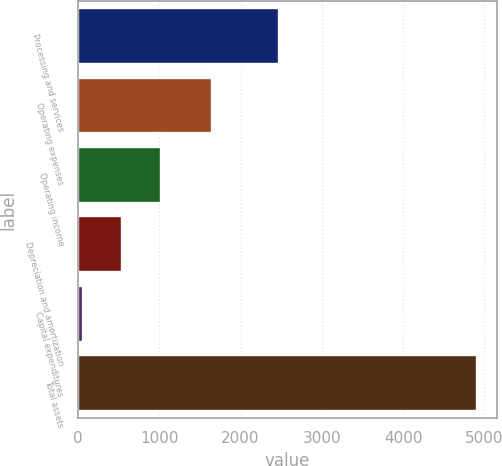Convert chart to OTSL. <chart><loc_0><loc_0><loc_500><loc_500><bar_chart><fcel>Processing and services<fcel>Operating expenses<fcel>Operating income<fcel>Depreciation and amortization<fcel>Capital expenditures<fcel>Total assets<nl><fcel>2478.1<fcel>1643.1<fcel>1026.42<fcel>541.51<fcel>56.6<fcel>4905.7<nl></chart> 